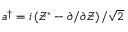Convert formula to latex. <formula><loc_0><loc_0><loc_500><loc_500>a ^ { \dag } = { i } \left ( \mathcal { Z } ^ { * } - { \partial } / { \partial \mathcal { Z } } \right ) / { \sqrt { 2 } }</formula> 